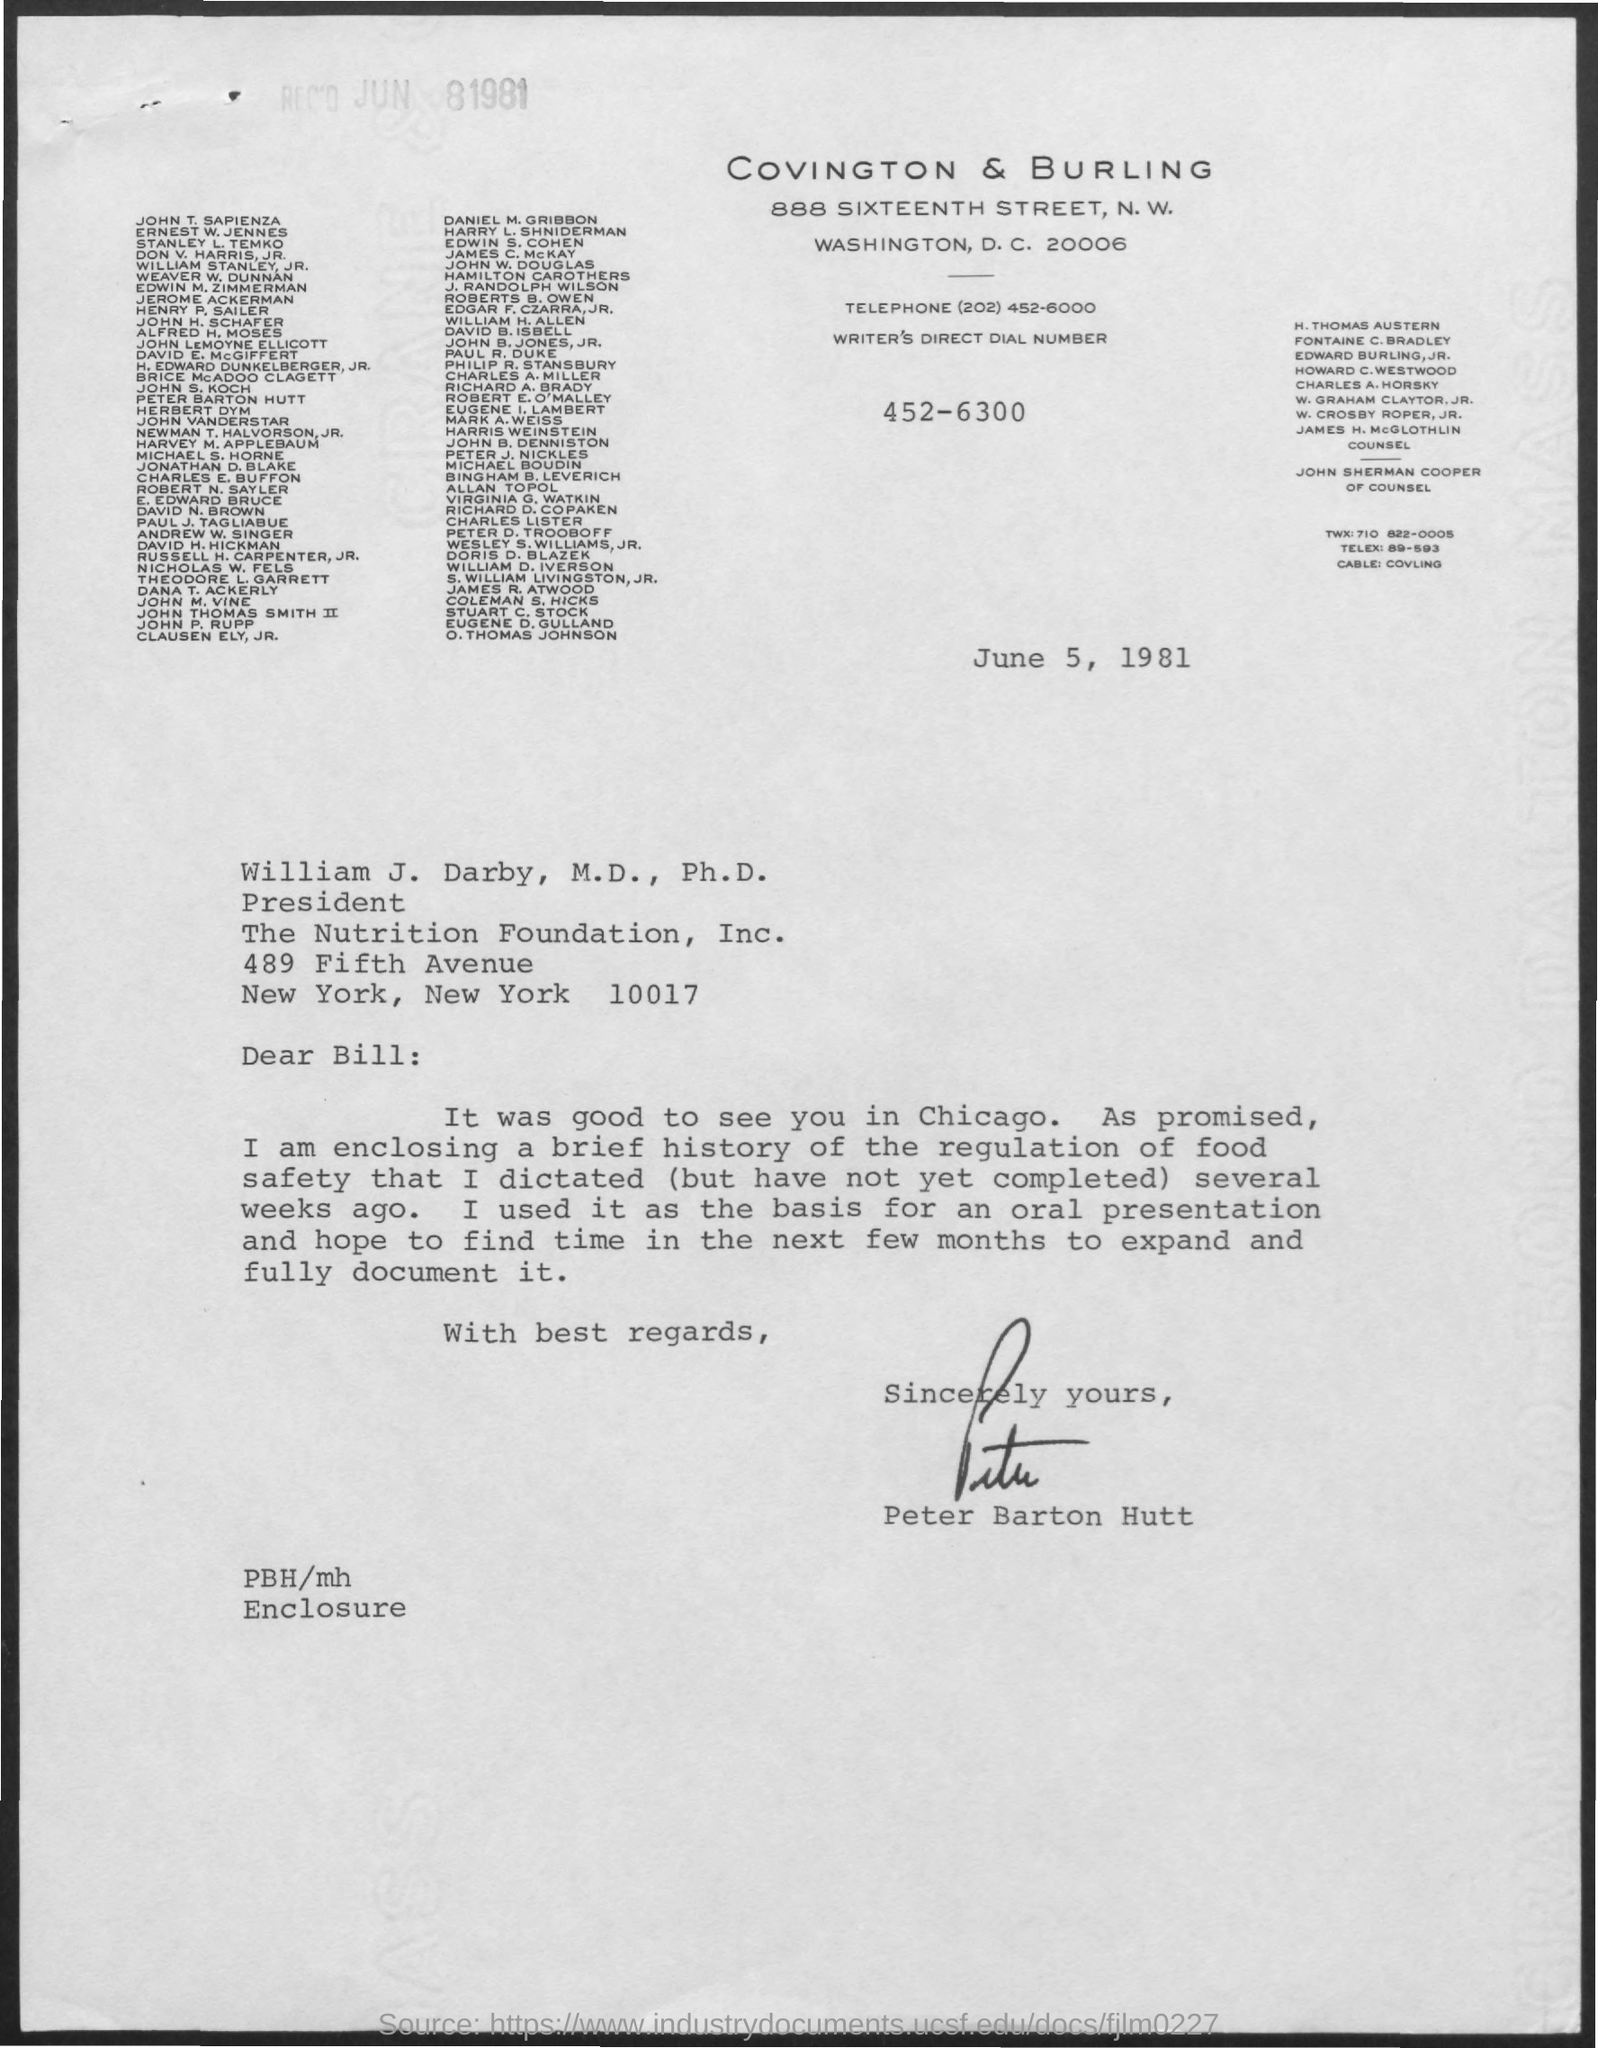What is the date mentioned ?
Provide a short and direct response. June 5, 1981. This letter is written by whom
Provide a succinct answer. Peter Barton Hutt. 